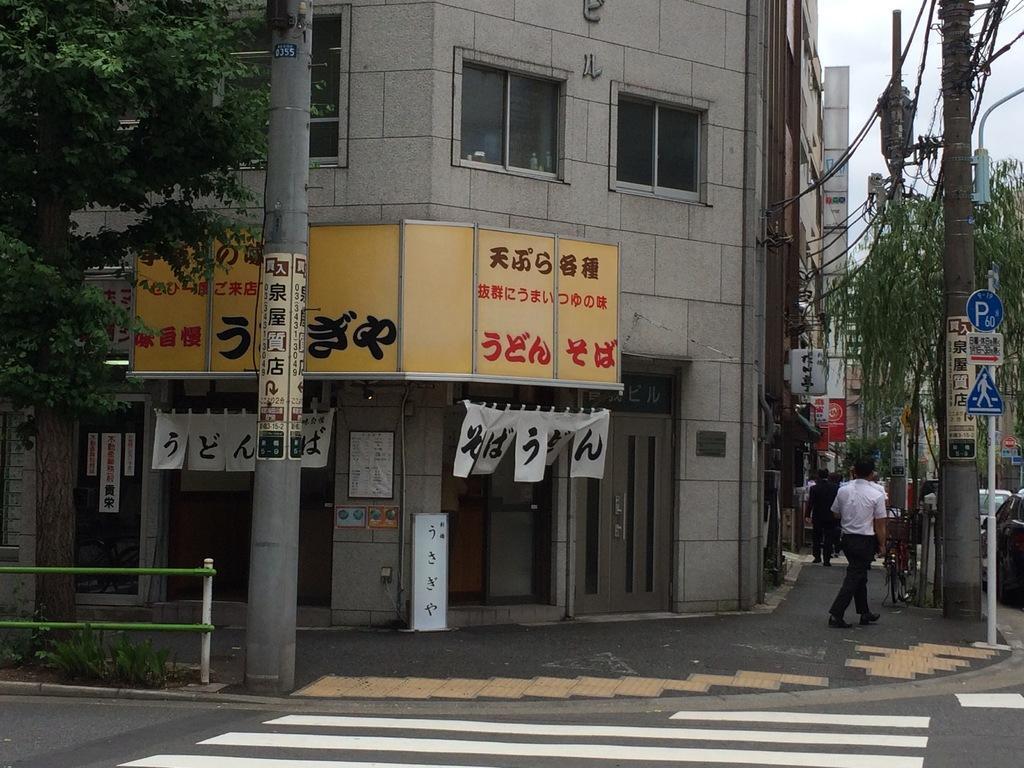Can you describe this image briefly? In this image in the center there is and building, and on the right side there are some trees, poles, wires, boards and some persons are walking and some vehicles. At the bottom three is road, railing, plants and some boards. On the boards there is text and on the left side there are trees. 